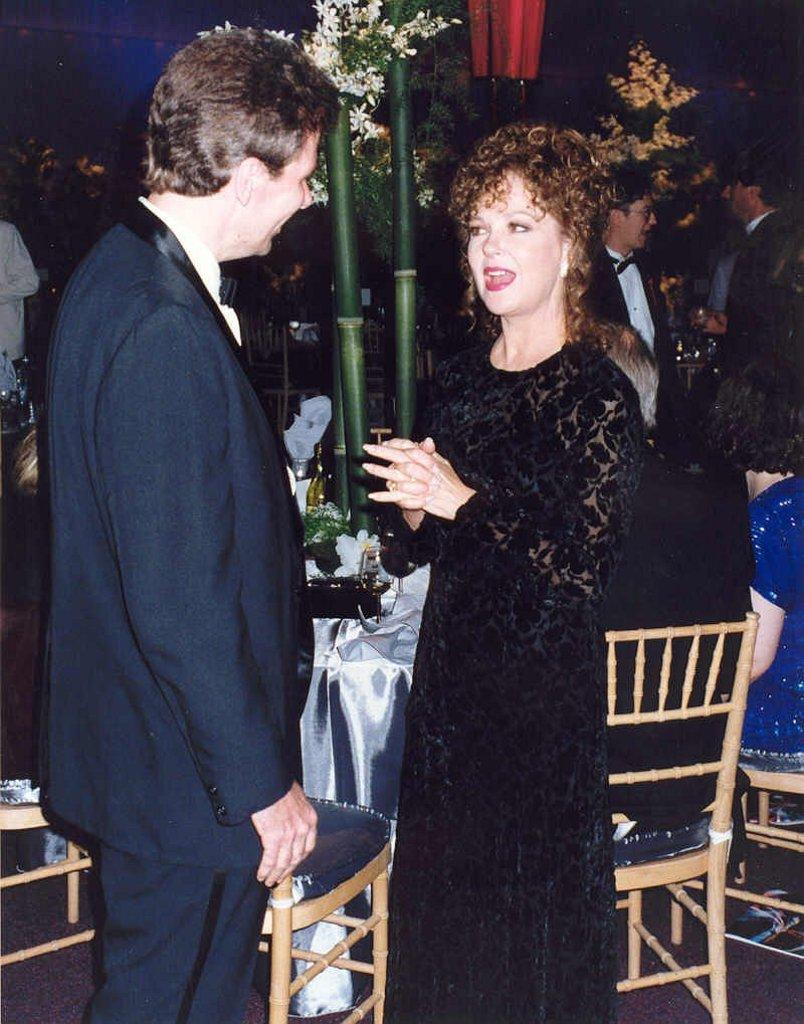What is the general setting of the image? There are many people present outside. What furniture is visible in the image? There is a chair and a table in the image. How are the two persons at the table interacting? The two persons are sitting at the table and talking to each other. How many trees are visible in the image? There are no trees visible in the image. What type of cracker is on the table? There is no cracker present on the table in the image. 